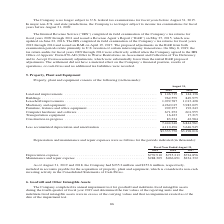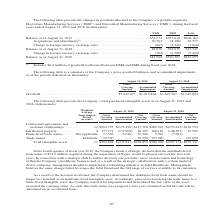According to Jabil Circuit's financial document, What did Acquisitions and adjustments include? $8.2 million of goodwill reallocated between DMS and EMS during fiscal year 2018.. The document states: "(1) Includes $8.2 million of goodwill reallocated between DMS and EMS during fiscal year 2018...." Also, What was the Balance as of August 31, 2017 in EMS? According to the financial document, $52,574 (in thousands). The relevant text states: "Balance as of August 31, 2017 . $52,574 $555,610 $608,184 Acquisitions and adjustments (1) . 30,763 (8,186) 22,577 Change in foreign currenc..." Also, Which years does the company provide information for changes in goodwill allocated to the Company's reportable segments? The document shows two values: 2018 and 2019. From the document: "Balance as of August 31, 2019 . $81,968 $540,287 $622,255 Balance as of August 31, 2018 . 82,670 545,075 627,745 Change in foreign currency exchange r..." Also, can you calculate: What is the difference in Acquisitions and adjustments in fiscal 2018 between EMS and DMS? Based on the calculation: 30,763-(-8,186), the result is 38949 (in thousands). This is based on the information: "08,184 Acquisitions and adjustments (1) . 30,763 (8,186) 22,577 Change in foreign currency exchange rates . (667) (2,349) (3,016) 5,610 $608,184 Acquisitions and adjustments (1) . 30,763 (8,186) 22,57..." The key data points involved are: 30,763, 8,186. Also, can you calculate: What was the balance of EMS as in 2018 as a percentage of the total balance at the end of fiscal 2018? Based on the calculation: 82,670/627,745, the result is 13.17 (percentage). This is based on the information: "Balance as of August 31, 2018 . 82,670 545,075 627,745 Change in foreign currency exchange rates . (702) (4,788) (5,490) Balance as of August 31, 2018 . 82,670 545,075 627,745 Change in foreign curren..." The key data points involved are: 627,745, 82,670. Also, can you calculate: What was the percentage change in total balance between 2018 and 2019? To answer this question, I need to perform calculations using the financial data. The calculation is: ($622,255-627,745)/627,745, which equals -0.87 (percentage). This is based on the information: "Balance as of August 31, 2019 . $81,968 $540,287 $622,255 Balance as of August 31, 2018 . 82,670 545,075 627,745 Change in foreign currency exchange rates . (702) (4,788) (5,490)..." The key data points involved are: 622,255, 627,745. 